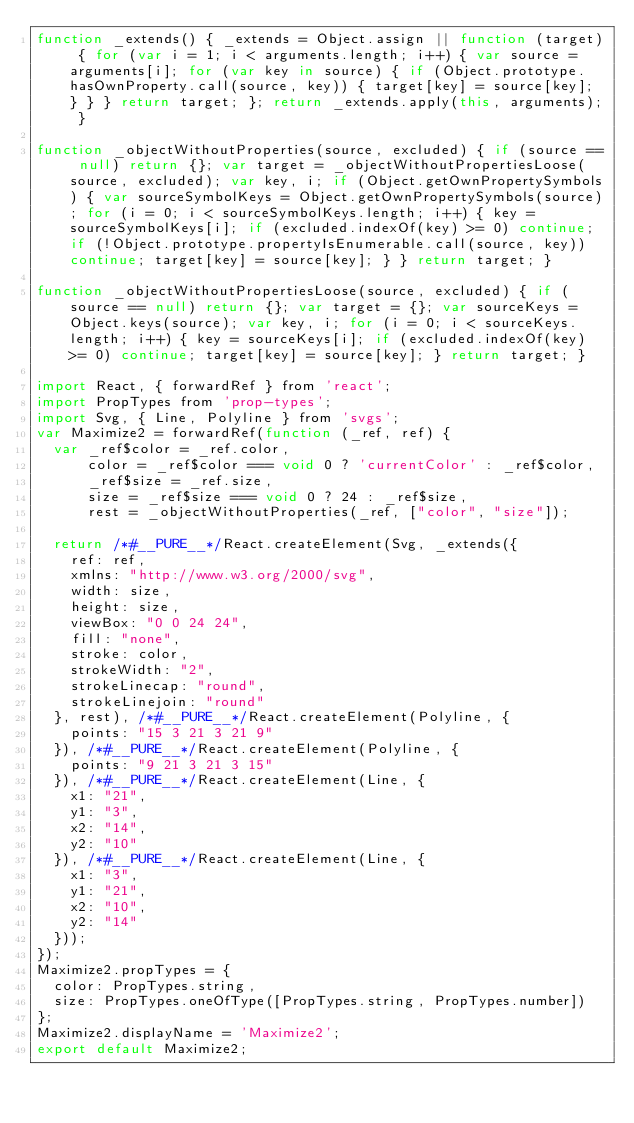<code> <loc_0><loc_0><loc_500><loc_500><_JavaScript_>function _extends() { _extends = Object.assign || function (target) { for (var i = 1; i < arguments.length; i++) { var source = arguments[i]; for (var key in source) { if (Object.prototype.hasOwnProperty.call(source, key)) { target[key] = source[key]; } } } return target; }; return _extends.apply(this, arguments); }

function _objectWithoutProperties(source, excluded) { if (source == null) return {}; var target = _objectWithoutPropertiesLoose(source, excluded); var key, i; if (Object.getOwnPropertySymbols) { var sourceSymbolKeys = Object.getOwnPropertySymbols(source); for (i = 0; i < sourceSymbolKeys.length; i++) { key = sourceSymbolKeys[i]; if (excluded.indexOf(key) >= 0) continue; if (!Object.prototype.propertyIsEnumerable.call(source, key)) continue; target[key] = source[key]; } } return target; }

function _objectWithoutPropertiesLoose(source, excluded) { if (source == null) return {}; var target = {}; var sourceKeys = Object.keys(source); var key, i; for (i = 0; i < sourceKeys.length; i++) { key = sourceKeys[i]; if (excluded.indexOf(key) >= 0) continue; target[key] = source[key]; } return target; }

import React, { forwardRef } from 'react';
import PropTypes from 'prop-types';
import Svg, { Line, Polyline } from 'svgs';
var Maximize2 = forwardRef(function (_ref, ref) {
  var _ref$color = _ref.color,
      color = _ref$color === void 0 ? 'currentColor' : _ref$color,
      _ref$size = _ref.size,
      size = _ref$size === void 0 ? 24 : _ref$size,
      rest = _objectWithoutProperties(_ref, ["color", "size"]);

  return /*#__PURE__*/React.createElement(Svg, _extends({
    ref: ref,
    xmlns: "http://www.w3.org/2000/svg",
    width: size,
    height: size,
    viewBox: "0 0 24 24",
    fill: "none",
    stroke: color,
    strokeWidth: "2",
    strokeLinecap: "round",
    strokeLinejoin: "round"
  }, rest), /*#__PURE__*/React.createElement(Polyline, {
    points: "15 3 21 3 21 9"
  }), /*#__PURE__*/React.createElement(Polyline, {
    points: "9 21 3 21 3 15"
  }), /*#__PURE__*/React.createElement(Line, {
    x1: "21",
    y1: "3",
    x2: "14",
    y2: "10"
  }), /*#__PURE__*/React.createElement(Line, {
    x1: "3",
    y1: "21",
    x2: "10",
    y2: "14"
  }));
});
Maximize2.propTypes = {
  color: PropTypes.string,
  size: PropTypes.oneOfType([PropTypes.string, PropTypes.number])
};
Maximize2.displayName = 'Maximize2';
export default Maximize2;</code> 